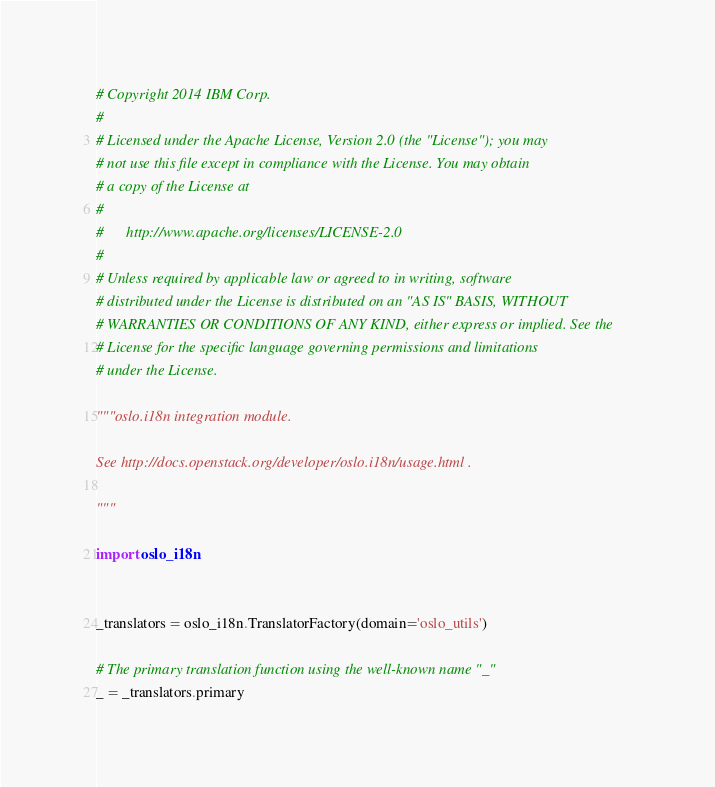<code> <loc_0><loc_0><loc_500><loc_500><_Python_># Copyright 2014 IBM Corp.
#
# Licensed under the Apache License, Version 2.0 (the "License"); you may
# not use this file except in compliance with the License. You may obtain
# a copy of the License at
#
#      http://www.apache.org/licenses/LICENSE-2.0
#
# Unless required by applicable law or agreed to in writing, software
# distributed under the License is distributed on an "AS IS" BASIS, WITHOUT
# WARRANTIES OR CONDITIONS OF ANY KIND, either express or implied. See the
# License for the specific language governing permissions and limitations
# under the License.

"""oslo.i18n integration module.

See http://docs.openstack.org/developer/oslo.i18n/usage.html .

"""

import oslo_i18n


_translators = oslo_i18n.TranslatorFactory(domain='oslo_utils')

# The primary translation function using the well-known name "_"
_ = _translators.primary
</code> 